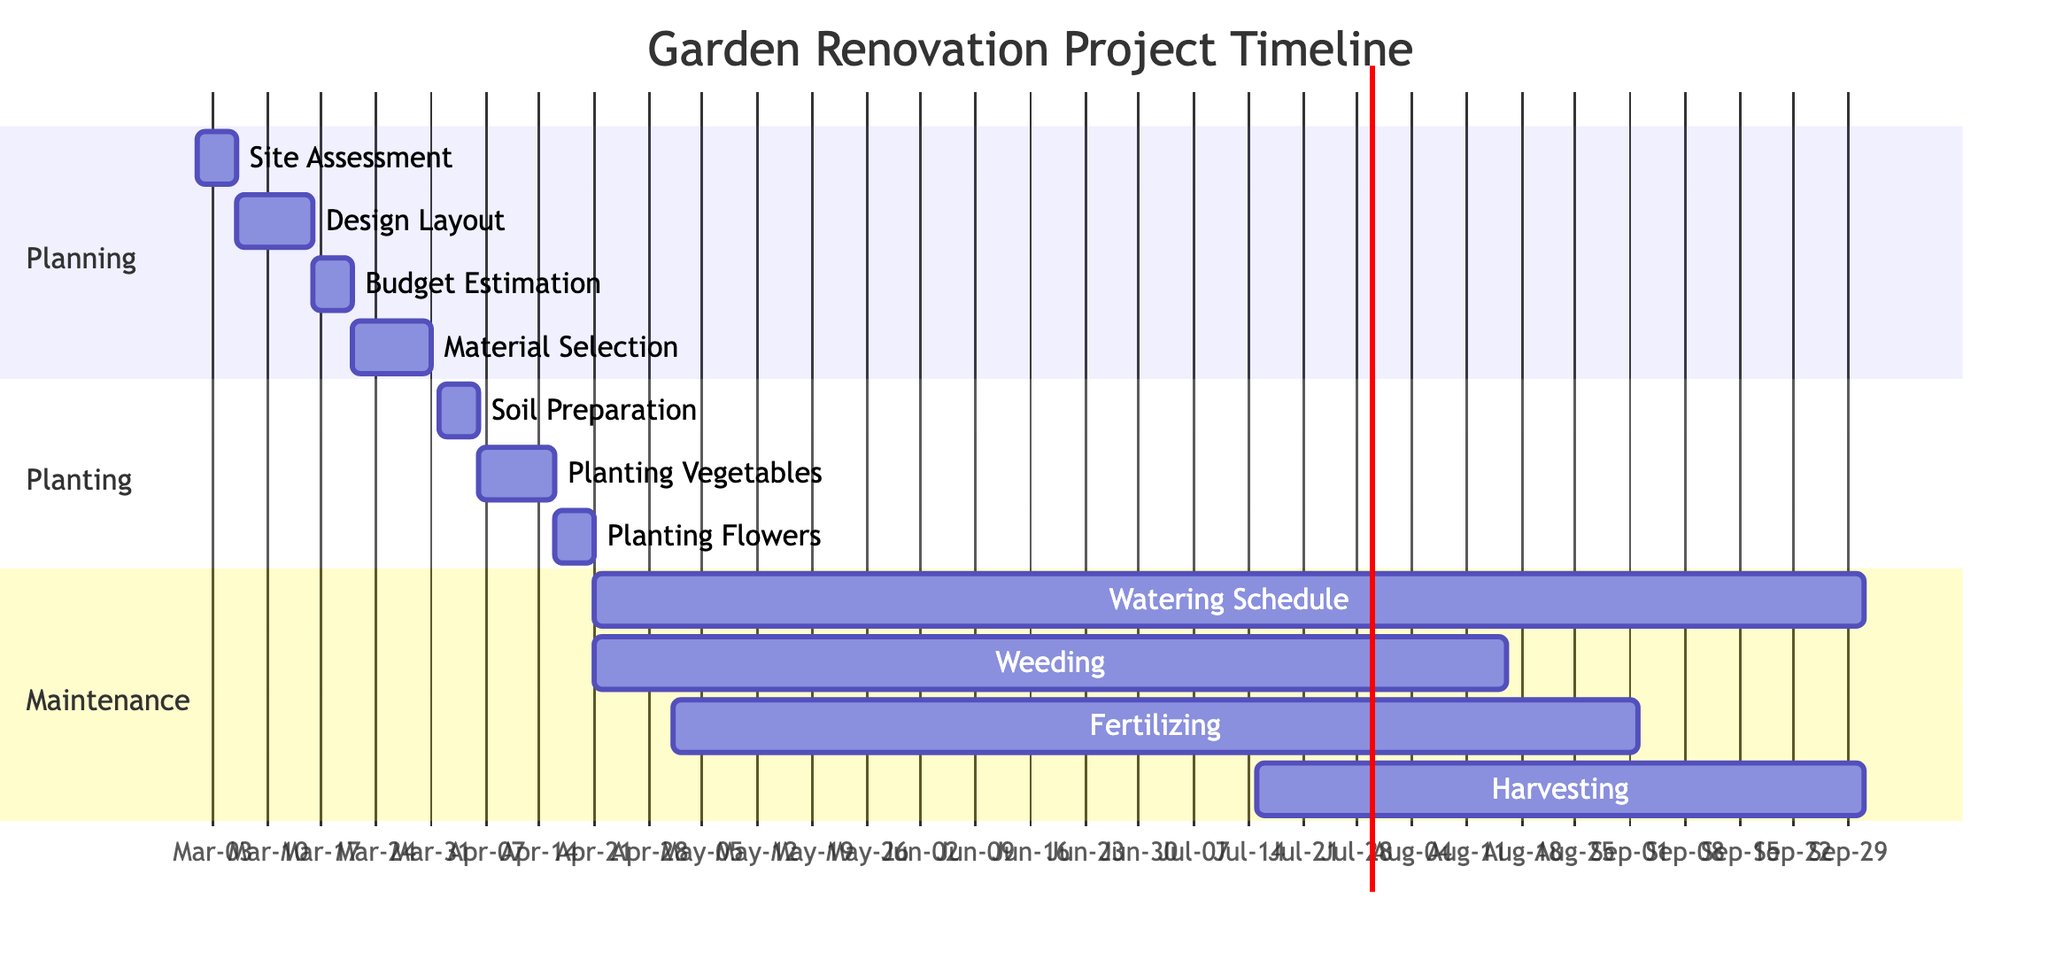What is the duration of the Planning phase? The Planning phase includes four tasks: Site Assessment (5 days), Design Layout (10 days), Budget Estimation (5 days), and Material Selection (10 days). Adding these durations together gives 30 days total for the Planning phase.
Answer: 30 days Which task in the Planting phase starts first? The Planting phase includes three tasks: Soil Preparation (starts on April 1), Planting Vegetables (starts on April 6), and Planting Flowers (starts on April 16). The earliest start date is for Soil Preparation.
Answer: Soil Preparation How many total tasks are in the Maintenance phase? The Maintenance phase includes four tasks: Watering Schedule, Weeding, Fertilizing, and Harvesting. Counting these gives a total of four tasks for the Maintenance phase.
Answer: 4 tasks What is the end date of the Watering Schedule task? The Watering Schedule task starts on April 21, 2024, and lasts for 163 days. To find the end date, we add 163 days to the start date, which results in a final end date of September 30, 2024.
Answer: September 30, 2024 Which task overlaps with the Fertilizing task? Fertilizing starts on May 1 and lasts until September 1, 2024. The tasks Watering Schedule (April 21 - September 30) and Weeding (April 21 - August 15) both begin before Fertilizing starts and extend into its duration.
Answer: Watering Schedule, Weeding 